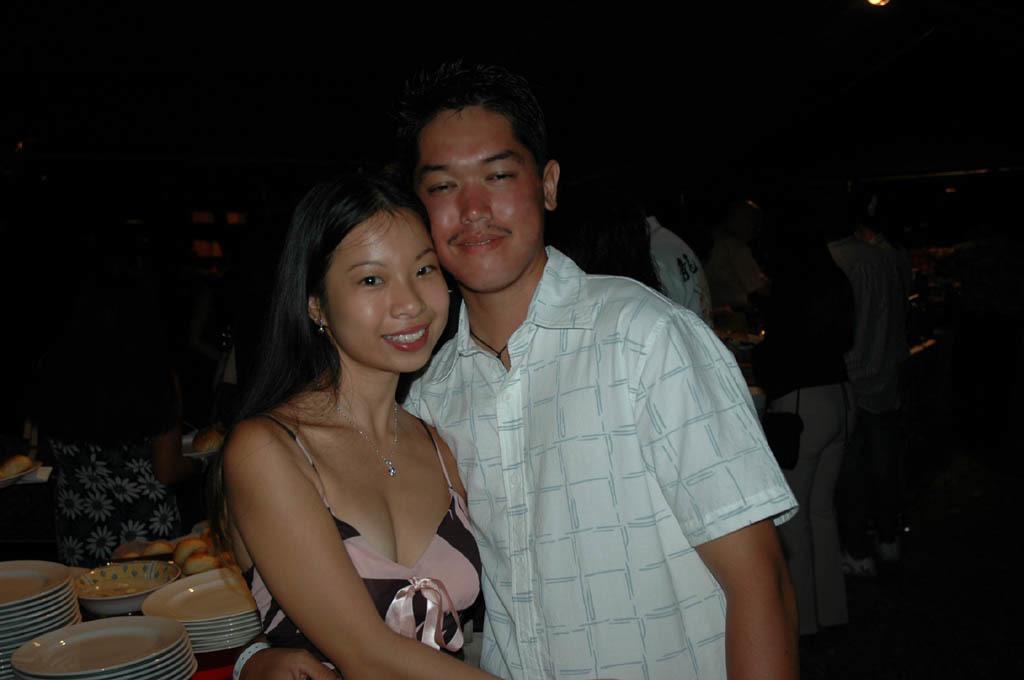Could you give a brief overview of what you see in this image? There is a man and a woman wearing chain. In the back there are many people. Also there is a platform with plates and many other items. In the background it is dark. 